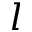Convert formula to latex. <formula><loc_0><loc_0><loc_500><loc_500>l</formula> 